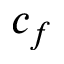Convert formula to latex. <formula><loc_0><loc_0><loc_500><loc_500>c _ { f }</formula> 